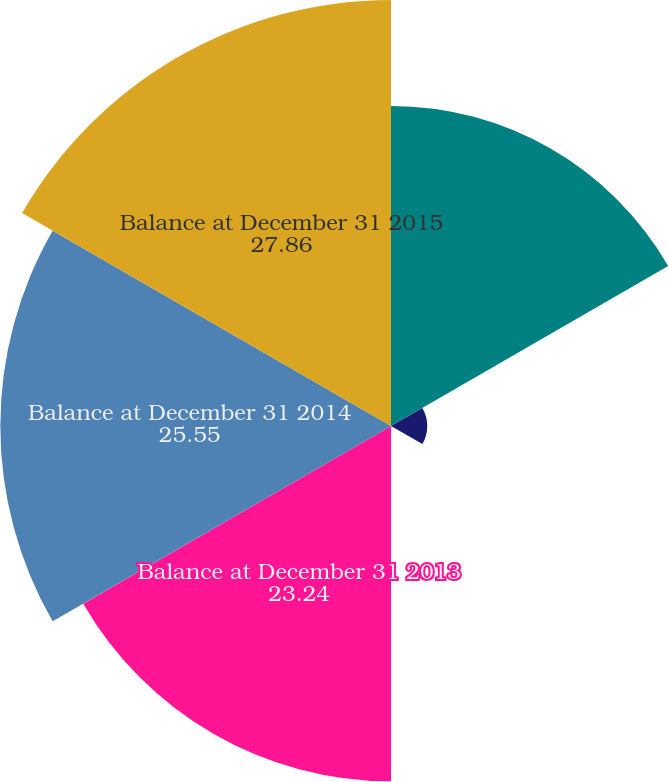Convert chart. <chart><loc_0><loc_0><loc_500><loc_500><pie_chart><fcel>Balance at December 31 2012<fcel>Acquisitions<fcel>Foreign currency translation<fcel>Balance at December 31 2013<fcel>Balance at December 31 2014<fcel>Balance at December 31 2015<nl><fcel>20.93%<fcel>2.37%<fcel>0.06%<fcel>23.24%<fcel>25.55%<fcel>27.86%<nl></chart> 